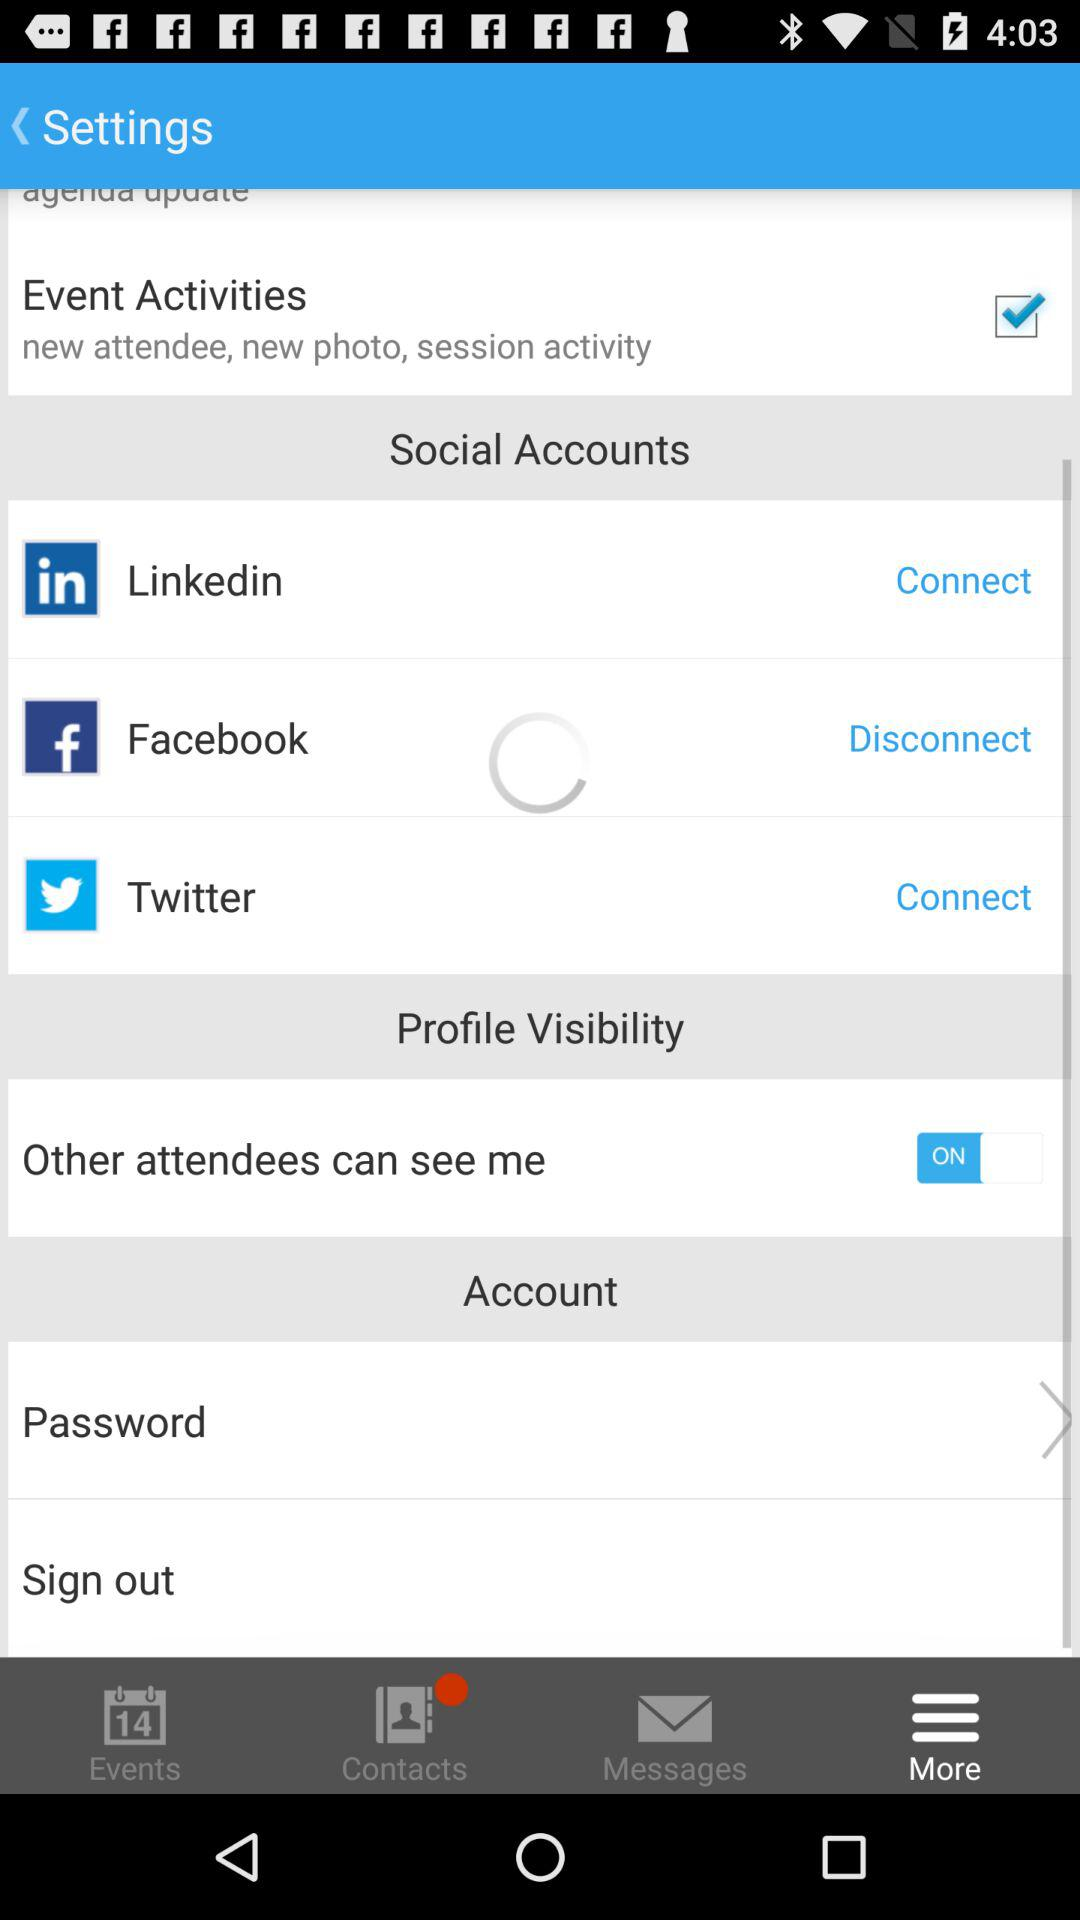Which application can I use to log in? You can log in via the applications "Linkedin", "Facebook" and "Twitter". 